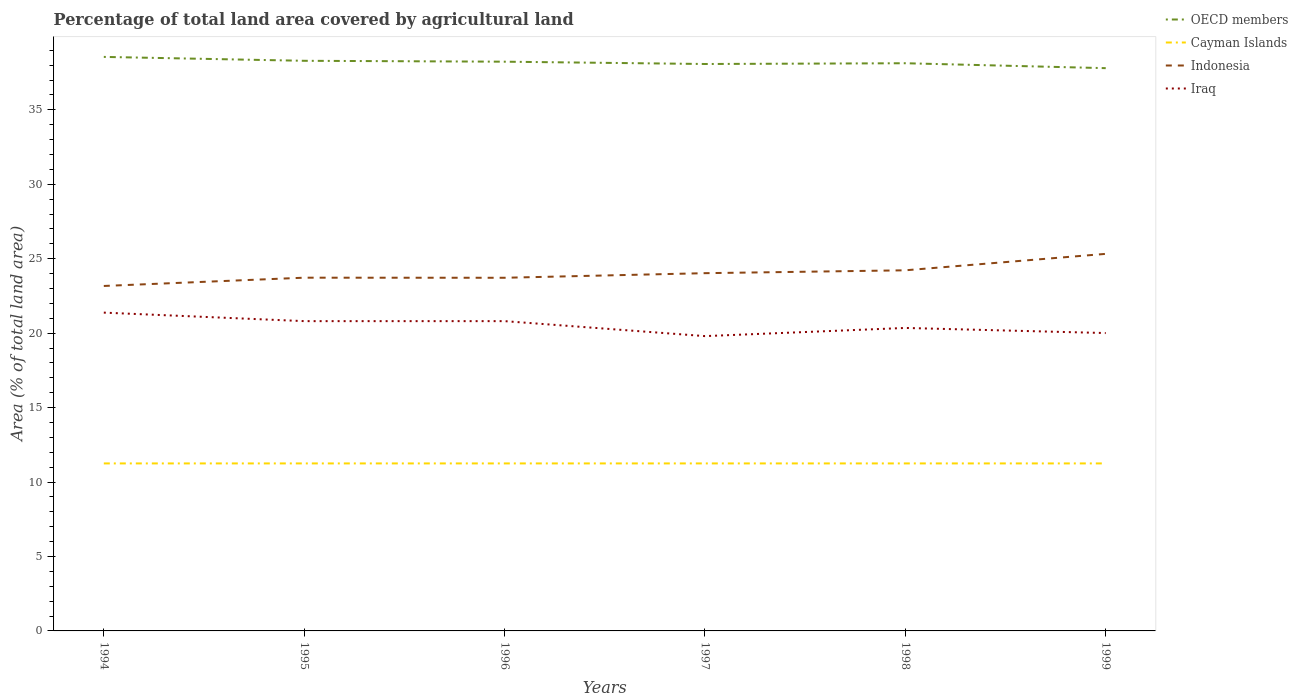Across all years, what is the maximum percentage of agricultural land in OECD members?
Offer a very short reply. 37.8. In which year was the percentage of agricultural land in Iraq maximum?
Your response must be concise. 1997. Is the percentage of agricultural land in Cayman Islands strictly greater than the percentage of agricultural land in OECD members over the years?
Your response must be concise. Yes. How many lines are there?
Provide a succinct answer. 4. Does the graph contain grids?
Your response must be concise. No. Where does the legend appear in the graph?
Provide a short and direct response. Top right. How are the legend labels stacked?
Offer a terse response. Vertical. What is the title of the graph?
Ensure brevity in your answer.  Percentage of total land area covered by agricultural land. Does "Other small states" appear as one of the legend labels in the graph?
Your response must be concise. No. What is the label or title of the X-axis?
Your answer should be compact. Years. What is the label or title of the Y-axis?
Give a very brief answer. Area (% of total land area). What is the Area (% of total land area) of OECD members in 1994?
Keep it short and to the point. 38.55. What is the Area (% of total land area) of Cayman Islands in 1994?
Your response must be concise. 11.25. What is the Area (% of total land area) of Indonesia in 1994?
Ensure brevity in your answer.  23.17. What is the Area (% of total land area) in Iraq in 1994?
Offer a terse response. 21.38. What is the Area (% of total land area) in OECD members in 1995?
Make the answer very short. 38.29. What is the Area (% of total land area) of Cayman Islands in 1995?
Provide a short and direct response. 11.25. What is the Area (% of total land area) of Indonesia in 1995?
Your response must be concise. 23.72. What is the Area (% of total land area) in Iraq in 1995?
Your response must be concise. 20.81. What is the Area (% of total land area) in OECD members in 1996?
Your answer should be very brief. 38.23. What is the Area (% of total land area) of Cayman Islands in 1996?
Your answer should be very brief. 11.25. What is the Area (% of total land area) in Indonesia in 1996?
Give a very brief answer. 23.72. What is the Area (% of total land area) in Iraq in 1996?
Your answer should be very brief. 20.81. What is the Area (% of total land area) of OECD members in 1997?
Provide a short and direct response. 38.08. What is the Area (% of total land area) in Cayman Islands in 1997?
Give a very brief answer. 11.25. What is the Area (% of total land area) in Indonesia in 1997?
Your response must be concise. 24.03. What is the Area (% of total land area) in Iraq in 1997?
Make the answer very short. 19.8. What is the Area (% of total land area) of OECD members in 1998?
Your response must be concise. 38.13. What is the Area (% of total land area) in Cayman Islands in 1998?
Offer a very short reply. 11.25. What is the Area (% of total land area) in Indonesia in 1998?
Offer a terse response. 24.22. What is the Area (% of total land area) in Iraq in 1998?
Provide a succinct answer. 20.35. What is the Area (% of total land area) in OECD members in 1999?
Ensure brevity in your answer.  37.8. What is the Area (% of total land area) of Cayman Islands in 1999?
Your response must be concise. 11.25. What is the Area (% of total land area) of Indonesia in 1999?
Your answer should be very brief. 25.32. What is the Area (% of total land area) in Iraq in 1999?
Make the answer very short. 20.01. Across all years, what is the maximum Area (% of total land area) of OECD members?
Your answer should be very brief. 38.55. Across all years, what is the maximum Area (% of total land area) of Cayman Islands?
Keep it short and to the point. 11.25. Across all years, what is the maximum Area (% of total land area) in Indonesia?
Keep it short and to the point. 25.32. Across all years, what is the maximum Area (% of total land area) in Iraq?
Keep it short and to the point. 21.38. Across all years, what is the minimum Area (% of total land area) of OECD members?
Offer a very short reply. 37.8. Across all years, what is the minimum Area (% of total land area) of Cayman Islands?
Your answer should be very brief. 11.25. Across all years, what is the minimum Area (% of total land area) of Indonesia?
Keep it short and to the point. 23.17. Across all years, what is the minimum Area (% of total land area) in Iraq?
Your response must be concise. 19.8. What is the total Area (% of total land area) of OECD members in the graph?
Your answer should be very brief. 229.07. What is the total Area (% of total land area) in Cayman Islands in the graph?
Give a very brief answer. 67.5. What is the total Area (% of total land area) of Indonesia in the graph?
Give a very brief answer. 144.18. What is the total Area (% of total land area) of Iraq in the graph?
Offer a terse response. 123.15. What is the difference between the Area (% of total land area) in OECD members in 1994 and that in 1995?
Your answer should be compact. 0.26. What is the difference between the Area (% of total land area) of Cayman Islands in 1994 and that in 1995?
Your response must be concise. 0. What is the difference between the Area (% of total land area) in Indonesia in 1994 and that in 1995?
Give a very brief answer. -0.56. What is the difference between the Area (% of total land area) in Iraq in 1994 and that in 1995?
Your response must be concise. 0.57. What is the difference between the Area (% of total land area) of OECD members in 1994 and that in 1996?
Ensure brevity in your answer.  0.32. What is the difference between the Area (% of total land area) of Cayman Islands in 1994 and that in 1996?
Provide a short and direct response. 0. What is the difference between the Area (% of total land area) of Indonesia in 1994 and that in 1996?
Ensure brevity in your answer.  -0.55. What is the difference between the Area (% of total land area) in Iraq in 1994 and that in 1996?
Provide a short and direct response. 0.57. What is the difference between the Area (% of total land area) of OECD members in 1994 and that in 1997?
Your answer should be compact. 0.48. What is the difference between the Area (% of total land area) of Cayman Islands in 1994 and that in 1997?
Ensure brevity in your answer.  0. What is the difference between the Area (% of total land area) in Indonesia in 1994 and that in 1997?
Keep it short and to the point. -0.86. What is the difference between the Area (% of total land area) of Iraq in 1994 and that in 1997?
Offer a terse response. 1.58. What is the difference between the Area (% of total land area) in OECD members in 1994 and that in 1998?
Your answer should be compact. 0.43. What is the difference between the Area (% of total land area) in Cayman Islands in 1994 and that in 1998?
Provide a succinct answer. 0. What is the difference between the Area (% of total land area) in Indonesia in 1994 and that in 1998?
Your answer should be very brief. -1.05. What is the difference between the Area (% of total land area) in Iraq in 1994 and that in 1998?
Provide a short and direct response. 1.03. What is the difference between the Area (% of total land area) of OECD members in 1994 and that in 1999?
Offer a terse response. 0.76. What is the difference between the Area (% of total land area) in Indonesia in 1994 and that in 1999?
Your answer should be very brief. -2.16. What is the difference between the Area (% of total land area) in Iraq in 1994 and that in 1999?
Ensure brevity in your answer.  1.37. What is the difference between the Area (% of total land area) of OECD members in 1995 and that in 1996?
Your answer should be compact. 0.06. What is the difference between the Area (% of total land area) in Indonesia in 1995 and that in 1996?
Your answer should be compact. 0.01. What is the difference between the Area (% of total land area) of OECD members in 1995 and that in 1997?
Ensure brevity in your answer.  0.22. What is the difference between the Area (% of total land area) in Indonesia in 1995 and that in 1997?
Give a very brief answer. -0.3. What is the difference between the Area (% of total land area) of OECD members in 1995 and that in 1998?
Offer a terse response. 0.16. What is the difference between the Area (% of total land area) of Indonesia in 1995 and that in 1998?
Offer a very short reply. -0.5. What is the difference between the Area (% of total land area) of Iraq in 1995 and that in 1998?
Your answer should be very brief. 0.46. What is the difference between the Area (% of total land area) of OECD members in 1995 and that in 1999?
Keep it short and to the point. 0.49. What is the difference between the Area (% of total land area) in Indonesia in 1995 and that in 1999?
Provide a succinct answer. -1.6. What is the difference between the Area (% of total land area) in Iraq in 1995 and that in 1999?
Provide a succinct answer. 0.8. What is the difference between the Area (% of total land area) of OECD members in 1996 and that in 1997?
Offer a terse response. 0.16. What is the difference between the Area (% of total land area) of Indonesia in 1996 and that in 1997?
Offer a very short reply. -0.31. What is the difference between the Area (% of total land area) in Iraq in 1996 and that in 1997?
Offer a very short reply. 1.01. What is the difference between the Area (% of total land area) in OECD members in 1996 and that in 1998?
Your answer should be very brief. 0.1. What is the difference between the Area (% of total land area) of Indonesia in 1996 and that in 1998?
Offer a terse response. -0.5. What is the difference between the Area (% of total land area) in Iraq in 1996 and that in 1998?
Make the answer very short. 0.46. What is the difference between the Area (% of total land area) of OECD members in 1996 and that in 1999?
Provide a succinct answer. 0.43. What is the difference between the Area (% of total land area) in Indonesia in 1996 and that in 1999?
Your answer should be very brief. -1.61. What is the difference between the Area (% of total land area) of Iraq in 1996 and that in 1999?
Make the answer very short. 0.8. What is the difference between the Area (% of total land area) of OECD members in 1997 and that in 1998?
Keep it short and to the point. -0.05. What is the difference between the Area (% of total land area) of Cayman Islands in 1997 and that in 1998?
Your response must be concise. 0. What is the difference between the Area (% of total land area) of Indonesia in 1997 and that in 1998?
Your answer should be compact. -0.19. What is the difference between the Area (% of total land area) of Iraq in 1997 and that in 1998?
Your response must be concise. -0.55. What is the difference between the Area (% of total land area) of OECD members in 1997 and that in 1999?
Your response must be concise. 0.28. What is the difference between the Area (% of total land area) of Indonesia in 1997 and that in 1999?
Offer a very short reply. -1.3. What is the difference between the Area (% of total land area) in Iraq in 1997 and that in 1999?
Your response must be concise. -0.21. What is the difference between the Area (% of total land area) in OECD members in 1998 and that in 1999?
Offer a terse response. 0.33. What is the difference between the Area (% of total land area) in Cayman Islands in 1998 and that in 1999?
Your answer should be compact. 0. What is the difference between the Area (% of total land area) of Indonesia in 1998 and that in 1999?
Ensure brevity in your answer.  -1.1. What is the difference between the Area (% of total land area) in Iraq in 1998 and that in 1999?
Provide a short and direct response. 0.34. What is the difference between the Area (% of total land area) in OECD members in 1994 and the Area (% of total land area) in Cayman Islands in 1995?
Your response must be concise. 27.3. What is the difference between the Area (% of total land area) of OECD members in 1994 and the Area (% of total land area) of Indonesia in 1995?
Offer a very short reply. 14.83. What is the difference between the Area (% of total land area) of OECD members in 1994 and the Area (% of total land area) of Iraq in 1995?
Offer a terse response. 17.75. What is the difference between the Area (% of total land area) of Cayman Islands in 1994 and the Area (% of total land area) of Indonesia in 1995?
Your response must be concise. -12.47. What is the difference between the Area (% of total land area) in Cayman Islands in 1994 and the Area (% of total land area) in Iraq in 1995?
Provide a succinct answer. -9.56. What is the difference between the Area (% of total land area) in Indonesia in 1994 and the Area (% of total land area) in Iraq in 1995?
Provide a short and direct response. 2.36. What is the difference between the Area (% of total land area) of OECD members in 1994 and the Area (% of total land area) of Cayman Islands in 1996?
Give a very brief answer. 27.3. What is the difference between the Area (% of total land area) of OECD members in 1994 and the Area (% of total land area) of Indonesia in 1996?
Keep it short and to the point. 14.83. What is the difference between the Area (% of total land area) of OECD members in 1994 and the Area (% of total land area) of Iraq in 1996?
Offer a terse response. 17.75. What is the difference between the Area (% of total land area) in Cayman Islands in 1994 and the Area (% of total land area) in Indonesia in 1996?
Make the answer very short. -12.47. What is the difference between the Area (% of total land area) in Cayman Islands in 1994 and the Area (% of total land area) in Iraq in 1996?
Give a very brief answer. -9.56. What is the difference between the Area (% of total land area) of Indonesia in 1994 and the Area (% of total land area) of Iraq in 1996?
Your answer should be very brief. 2.36. What is the difference between the Area (% of total land area) in OECD members in 1994 and the Area (% of total land area) in Cayman Islands in 1997?
Offer a very short reply. 27.3. What is the difference between the Area (% of total land area) of OECD members in 1994 and the Area (% of total land area) of Indonesia in 1997?
Offer a terse response. 14.53. What is the difference between the Area (% of total land area) of OECD members in 1994 and the Area (% of total land area) of Iraq in 1997?
Offer a terse response. 18.75. What is the difference between the Area (% of total land area) in Cayman Islands in 1994 and the Area (% of total land area) in Indonesia in 1997?
Make the answer very short. -12.78. What is the difference between the Area (% of total land area) of Cayman Islands in 1994 and the Area (% of total land area) of Iraq in 1997?
Provide a succinct answer. -8.55. What is the difference between the Area (% of total land area) of Indonesia in 1994 and the Area (% of total land area) of Iraq in 1997?
Offer a terse response. 3.37. What is the difference between the Area (% of total land area) of OECD members in 1994 and the Area (% of total land area) of Cayman Islands in 1998?
Make the answer very short. 27.3. What is the difference between the Area (% of total land area) in OECD members in 1994 and the Area (% of total land area) in Indonesia in 1998?
Keep it short and to the point. 14.33. What is the difference between the Area (% of total land area) in OECD members in 1994 and the Area (% of total land area) in Iraq in 1998?
Your answer should be very brief. 18.2. What is the difference between the Area (% of total land area) of Cayman Islands in 1994 and the Area (% of total land area) of Indonesia in 1998?
Give a very brief answer. -12.97. What is the difference between the Area (% of total land area) in Cayman Islands in 1994 and the Area (% of total land area) in Iraq in 1998?
Give a very brief answer. -9.1. What is the difference between the Area (% of total land area) of Indonesia in 1994 and the Area (% of total land area) of Iraq in 1998?
Offer a very short reply. 2.82. What is the difference between the Area (% of total land area) in OECD members in 1994 and the Area (% of total land area) in Cayman Islands in 1999?
Your response must be concise. 27.3. What is the difference between the Area (% of total land area) in OECD members in 1994 and the Area (% of total land area) in Indonesia in 1999?
Give a very brief answer. 13.23. What is the difference between the Area (% of total land area) in OECD members in 1994 and the Area (% of total land area) in Iraq in 1999?
Your response must be concise. 18.55. What is the difference between the Area (% of total land area) in Cayman Islands in 1994 and the Area (% of total land area) in Indonesia in 1999?
Give a very brief answer. -14.07. What is the difference between the Area (% of total land area) of Cayman Islands in 1994 and the Area (% of total land area) of Iraq in 1999?
Offer a very short reply. -8.76. What is the difference between the Area (% of total land area) of Indonesia in 1994 and the Area (% of total land area) of Iraq in 1999?
Your answer should be compact. 3.16. What is the difference between the Area (% of total land area) of OECD members in 1995 and the Area (% of total land area) of Cayman Islands in 1996?
Give a very brief answer. 27.04. What is the difference between the Area (% of total land area) in OECD members in 1995 and the Area (% of total land area) in Indonesia in 1996?
Make the answer very short. 14.57. What is the difference between the Area (% of total land area) in OECD members in 1995 and the Area (% of total land area) in Iraq in 1996?
Offer a terse response. 17.49. What is the difference between the Area (% of total land area) of Cayman Islands in 1995 and the Area (% of total land area) of Indonesia in 1996?
Your answer should be very brief. -12.47. What is the difference between the Area (% of total land area) in Cayman Islands in 1995 and the Area (% of total land area) in Iraq in 1996?
Offer a very short reply. -9.56. What is the difference between the Area (% of total land area) of Indonesia in 1995 and the Area (% of total land area) of Iraq in 1996?
Offer a very short reply. 2.92. What is the difference between the Area (% of total land area) of OECD members in 1995 and the Area (% of total land area) of Cayman Islands in 1997?
Your response must be concise. 27.04. What is the difference between the Area (% of total land area) of OECD members in 1995 and the Area (% of total land area) of Indonesia in 1997?
Offer a terse response. 14.26. What is the difference between the Area (% of total land area) of OECD members in 1995 and the Area (% of total land area) of Iraq in 1997?
Your answer should be very brief. 18.49. What is the difference between the Area (% of total land area) in Cayman Islands in 1995 and the Area (% of total land area) in Indonesia in 1997?
Your answer should be very brief. -12.78. What is the difference between the Area (% of total land area) in Cayman Islands in 1995 and the Area (% of total land area) in Iraq in 1997?
Your answer should be compact. -8.55. What is the difference between the Area (% of total land area) in Indonesia in 1995 and the Area (% of total land area) in Iraq in 1997?
Provide a succinct answer. 3.92. What is the difference between the Area (% of total land area) in OECD members in 1995 and the Area (% of total land area) in Cayman Islands in 1998?
Your answer should be very brief. 27.04. What is the difference between the Area (% of total land area) in OECD members in 1995 and the Area (% of total land area) in Indonesia in 1998?
Offer a terse response. 14.07. What is the difference between the Area (% of total land area) of OECD members in 1995 and the Area (% of total land area) of Iraq in 1998?
Give a very brief answer. 17.94. What is the difference between the Area (% of total land area) of Cayman Islands in 1995 and the Area (% of total land area) of Indonesia in 1998?
Provide a short and direct response. -12.97. What is the difference between the Area (% of total land area) in Cayman Islands in 1995 and the Area (% of total land area) in Iraq in 1998?
Your answer should be compact. -9.1. What is the difference between the Area (% of total land area) of Indonesia in 1995 and the Area (% of total land area) of Iraq in 1998?
Give a very brief answer. 3.38. What is the difference between the Area (% of total land area) in OECD members in 1995 and the Area (% of total land area) in Cayman Islands in 1999?
Keep it short and to the point. 27.04. What is the difference between the Area (% of total land area) in OECD members in 1995 and the Area (% of total land area) in Indonesia in 1999?
Provide a short and direct response. 12.97. What is the difference between the Area (% of total land area) of OECD members in 1995 and the Area (% of total land area) of Iraq in 1999?
Your response must be concise. 18.29. What is the difference between the Area (% of total land area) in Cayman Islands in 1995 and the Area (% of total land area) in Indonesia in 1999?
Your response must be concise. -14.07. What is the difference between the Area (% of total land area) of Cayman Islands in 1995 and the Area (% of total land area) of Iraq in 1999?
Offer a very short reply. -8.76. What is the difference between the Area (% of total land area) in Indonesia in 1995 and the Area (% of total land area) in Iraq in 1999?
Offer a terse response. 3.72. What is the difference between the Area (% of total land area) of OECD members in 1996 and the Area (% of total land area) of Cayman Islands in 1997?
Your answer should be compact. 26.98. What is the difference between the Area (% of total land area) in OECD members in 1996 and the Area (% of total land area) in Indonesia in 1997?
Make the answer very short. 14.2. What is the difference between the Area (% of total land area) in OECD members in 1996 and the Area (% of total land area) in Iraq in 1997?
Your answer should be very brief. 18.43. What is the difference between the Area (% of total land area) in Cayman Islands in 1996 and the Area (% of total land area) in Indonesia in 1997?
Your response must be concise. -12.78. What is the difference between the Area (% of total land area) of Cayman Islands in 1996 and the Area (% of total land area) of Iraq in 1997?
Provide a short and direct response. -8.55. What is the difference between the Area (% of total land area) of Indonesia in 1996 and the Area (% of total land area) of Iraq in 1997?
Your response must be concise. 3.92. What is the difference between the Area (% of total land area) in OECD members in 1996 and the Area (% of total land area) in Cayman Islands in 1998?
Give a very brief answer. 26.98. What is the difference between the Area (% of total land area) in OECD members in 1996 and the Area (% of total land area) in Indonesia in 1998?
Your answer should be compact. 14.01. What is the difference between the Area (% of total land area) in OECD members in 1996 and the Area (% of total land area) in Iraq in 1998?
Your answer should be compact. 17.88. What is the difference between the Area (% of total land area) of Cayman Islands in 1996 and the Area (% of total land area) of Indonesia in 1998?
Give a very brief answer. -12.97. What is the difference between the Area (% of total land area) in Cayman Islands in 1996 and the Area (% of total land area) in Iraq in 1998?
Offer a terse response. -9.1. What is the difference between the Area (% of total land area) of Indonesia in 1996 and the Area (% of total land area) of Iraq in 1998?
Your answer should be compact. 3.37. What is the difference between the Area (% of total land area) of OECD members in 1996 and the Area (% of total land area) of Cayman Islands in 1999?
Your response must be concise. 26.98. What is the difference between the Area (% of total land area) in OECD members in 1996 and the Area (% of total land area) in Indonesia in 1999?
Make the answer very short. 12.91. What is the difference between the Area (% of total land area) of OECD members in 1996 and the Area (% of total land area) of Iraq in 1999?
Your answer should be very brief. 18.23. What is the difference between the Area (% of total land area) in Cayman Islands in 1996 and the Area (% of total land area) in Indonesia in 1999?
Give a very brief answer. -14.07. What is the difference between the Area (% of total land area) of Cayman Islands in 1996 and the Area (% of total land area) of Iraq in 1999?
Make the answer very short. -8.76. What is the difference between the Area (% of total land area) in Indonesia in 1996 and the Area (% of total land area) in Iraq in 1999?
Keep it short and to the point. 3.71. What is the difference between the Area (% of total land area) of OECD members in 1997 and the Area (% of total land area) of Cayman Islands in 1998?
Your answer should be compact. 26.83. What is the difference between the Area (% of total land area) of OECD members in 1997 and the Area (% of total land area) of Indonesia in 1998?
Give a very brief answer. 13.86. What is the difference between the Area (% of total land area) of OECD members in 1997 and the Area (% of total land area) of Iraq in 1998?
Ensure brevity in your answer.  17.73. What is the difference between the Area (% of total land area) in Cayman Islands in 1997 and the Area (% of total land area) in Indonesia in 1998?
Provide a succinct answer. -12.97. What is the difference between the Area (% of total land area) of Cayman Islands in 1997 and the Area (% of total land area) of Iraq in 1998?
Keep it short and to the point. -9.1. What is the difference between the Area (% of total land area) of Indonesia in 1997 and the Area (% of total land area) of Iraq in 1998?
Your answer should be very brief. 3.68. What is the difference between the Area (% of total land area) of OECD members in 1997 and the Area (% of total land area) of Cayman Islands in 1999?
Your response must be concise. 26.83. What is the difference between the Area (% of total land area) of OECD members in 1997 and the Area (% of total land area) of Indonesia in 1999?
Keep it short and to the point. 12.75. What is the difference between the Area (% of total land area) of OECD members in 1997 and the Area (% of total land area) of Iraq in 1999?
Your answer should be very brief. 18.07. What is the difference between the Area (% of total land area) in Cayman Islands in 1997 and the Area (% of total land area) in Indonesia in 1999?
Provide a succinct answer. -14.07. What is the difference between the Area (% of total land area) of Cayman Islands in 1997 and the Area (% of total land area) of Iraq in 1999?
Your answer should be compact. -8.76. What is the difference between the Area (% of total land area) in Indonesia in 1997 and the Area (% of total land area) in Iraq in 1999?
Provide a succinct answer. 4.02. What is the difference between the Area (% of total land area) of OECD members in 1998 and the Area (% of total land area) of Cayman Islands in 1999?
Provide a short and direct response. 26.88. What is the difference between the Area (% of total land area) in OECD members in 1998 and the Area (% of total land area) in Indonesia in 1999?
Make the answer very short. 12.8. What is the difference between the Area (% of total land area) in OECD members in 1998 and the Area (% of total land area) in Iraq in 1999?
Your response must be concise. 18.12. What is the difference between the Area (% of total land area) in Cayman Islands in 1998 and the Area (% of total land area) in Indonesia in 1999?
Make the answer very short. -14.07. What is the difference between the Area (% of total land area) of Cayman Islands in 1998 and the Area (% of total land area) of Iraq in 1999?
Provide a succinct answer. -8.76. What is the difference between the Area (% of total land area) of Indonesia in 1998 and the Area (% of total land area) of Iraq in 1999?
Offer a very short reply. 4.21. What is the average Area (% of total land area) of OECD members per year?
Provide a succinct answer. 38.18. What is the average Area (% of total land area) of Cayman Islands per year?
Your response must be concise. 11.25. What is the average Area (% of total land area) of Indonesia per year?
Your answer should be compact. 24.03. What is the average Area (% of total land area) of Iraq per year?
Your answer should be very brief. 20.52. In the year 1994, what is the difference between the Area (% of total land area) in OECD members and Area (% of total land area) in Cayman Islands?
Provide a short and direct response. 27.3. In the year 1994, what is the difference between the Area (% of total land area) of OECD members and Area (% of total land area) of Indonesia?
Make the answer very short. 15.38. In the year 1994, what is the difference between the Area (% of total land area) in OECD members and Area (% of total land area) in Iraq?
Ensure brevity in your answer.  17.17. In the year 1994, what is the difference between the Area (% of total land area) of Cayman Islands and Area (% of total land area) of Indonesia?
Your answer should be compact. -11.92. In the year 1994, what is the difference between the Area (% of total land area) of Cayman Islands and Area (% of total land area) of Iraq?
Your answer should be compact. -10.13. In the year 1994, what is the difference between the Area (% of total land area) in Indonesia and Area (% of total land area) in Iraq?
Make the answer very short. 1.79. In the year 1995, what is the difference between the Area (% of total land area) of OECD members and Area (% of total land area) of Cayman Islands?
Offer a very short reply. 27.04. In the year 1995, what is the difference between the Area (% of total land area) of OECD members and Area (% of total land area) of Indonesia?
Provide a short and direct response. 14.57. In the year 1995, what is the difference between the Area (% of total land area) in OECD members and Area (% of total land area) in Iraq?
Offer a very short reply. 17.49. In the year 1995, what is the difference between the Area (% of total land area) in Cayman Islands and Area (% of total land area) in Indonesia?
Your response must be concise. -12.47. In the year 1995, what is the difference between the Area (% of total land area) of Cayman Islands and Area (% of total land area) of Iraq?
Your response must be concise. -9.56. In the year 1995, what is the difference between the Area (% of total land area) of Indonesia and Area (% of total land area) of Iraq?
Give a very brief answer. 2.92. In the year 1996, what is the difference between the Area (% of total land area) of OECD members and Area (% of total land area) of Cayman Islands?
Offer a very short reply. 26.98. In the year 1996, what is the difference between the Area (% of total land area) of OECD members and Area (% of total land area) of Indonesia?
Provide a short and direct response. 14.51. In the year 1996, what is the difference between the Area (% of total land area) in OECD members and Area (% of total land area) in Iraq?
Give a very brief answer. 17.43. In the year 1996, what is the difference between the Area (% of total land area) in Cayman Islands and Area (% of total land area) in Indonesia?
Your answer should be compact. -12.47. In the year 1996, what is the difference between the Area (% of total land area) of Cayman Islands and Area (% of total land area) of Iraq?
Provide a short and direct response. -9.56. In the year 1996, what is the difference between the Area (% of total land area) of Indonesia and Area (% of total land area) of Iraq?
Offer a very short reply. 2.91. In the year 1997, what is the difference between the Area (% of total land area) of OECD members and Area (% of total land area) of Cayman Islands?
Provide a succinct answer. 26.83. In the year 1997, what is the difference between the Area (% of total land area) of OECD members and Area (% of total land area) of Indonesia?
Your answer should be compact. 14.05. In the year 1997, what is the difference between the Area (% of total land area) in OECD members and Area (% of total land area) in Iraq?
Offer a very short reply. 18.28. In the year 1997, what is the difference between the Area (% of total land area) in Cayman Islands and Area (% of total land area) in Indonesia?
Provide a succinct answer. -12.78. In the year 1997, what is the difference between the Area (% of total land area) of Cayman Islands and Area (% of total land area) of Iraq?
Ensure brevity in your answer.  -8.55. In the year 1997, what is the difference between the Area (% of total land area) of Indonesia and Area (% of total land area) of Iraq?
Offer a very short reply. 4.23. In the year 1998, what is the difference between the Area (% of total land area) in OECD members and Area (% of total land area) in Cayman Islands?
Your response must be concise. 26.88. In the year 1998, what is the difference between the Area (% of total land area) in OECD members and Area (% of total land area) in Indonesia?
Offer a terse response. 13.91. In the year 1998, what is the difference between the Area (% of total land area) of OECD members and Area (% of total land area) of Iraq?
Your response must be concise. 17.78. In the year 1998, what is the difference between the Area (% of total land area) in Cayman Islands and Area (% of total land area) in Indonesia?
Ensure brevity in your answer.  -12.97. In the year 1998, what is the difference between the Area (% of total land area) of Cayman Islands and Area (% of total land area) of Iraq?
Give a very brief answer. -9.1. In the year 1998, what is the difference between the Area (% of total land area) in Indonesia and Area (% of total land area) in Iraq?
Keep it short and to the point. 3.87. In the year 1999, what is the difference between the Area (% of total land area) of OECD members and Area (% of total land area) of Cayman Islands?
Your response must be concise. 26.55. In the year 1999, what is the difference between the Area (% of total land area) in OECD members and Area (% of total land area) in Indonesia?
Your answer should be compact. 12.47. In the year 1999, what is the difference between the Area (% of total land area) of OECD members and Area (% of total land area) of Iraq?
Provide a succinct answer. 17.79. In the year 1999, what is the difference between the Area (% of total land area) in Cayman Islands and Area (% of total land area) in Indonesia?
Keep it short and to the point. -14.07. In the year 1999, what is the difference between the Area (% of total land area) of Cayman Islands and Area (% of total land area) of Iraq?
Ensure brevity in your answer.  -8.76. In the year 1999, what is the difference between the Area (% of total land area) of Indonesia and Area (% of total land area) of Iraq?
Your answer should be compact. 5.32. What is the ratio of the Area (% of total land area) in OECD members in 1994 to that in 1995?
Your answer should be very brief. 1.01. What is the ratio of the Area (% of total land area) in Indonesia in 1994 to that in 1995?
Give a very brief answer. 0.98. What is the ratio of the Area (% of total land area) of Iraq in 1994 to that in 1995?
Ensure brevity in your answer.  1.03. What is the ratio of the Area (% of total land area) of OECD members in 1994 to that in 1996?
Provide a succinct answer. 1.01. What is the ratio of the Area (% of total land area) in Cayman Islands in 1994 to that in 1996?
Ensure brevity in your answer.  1. What is the ratio of the Area (% of total land area) of Indonesia in 1994 to that in 1996?
Ensure brevity in your answer.  0.98. What is the ratio of the Area (% of total land area) in Iraq in 1994 to that in 1996?
Your answer should be very brief. 1.03. What is the ratio of the Area (% of total land area) in OECD members in 1994 to that in 1997?
Your answer should be very brief. 1.01. What is the ratio of the Area (% of total land area) in Indonesia in 1994 to that in 1997?
Keep it short and to the point. 0.96. What is the ratio of the Area (% of total land area) of Iraq in 1994 to that in 1997?
Provide a short and direct response. 1.08. What is the ratio of the Area (% of total land area) of OECD members in 1994 to that in 1998?
Provide a succinct answer. 1.01. What is the ratio of the Area (% of total land area) of Indonesia in 1994 to that in 1998?
Give a very brief answer. 0.96. What is the ratio of the Area (% of total land area) in Iraq in 1994 to that in 1998?
Ensure brevity in your answer.  1.05. What is the ratio of the Area (% of total land area) of Cayman Islands in 1994 to that in 1999?
Give a very brief answer. 1. What is the ratio of the Area (% of total land area) of Indonesia in 1994 to that in 1999?
Give a very brief answer. 0.91. What is the ratio of the Area (% of total land area) of Iraq in 1994 to that in 1999?
Ensure brevity in your answer.  1.07. What is the ratio of the Area (% of total land area) of Cayman Islands in 1995 to that in 1996?
Make the answer very short. 1. What is the ratio of the Area (% of total land area) of OECD members in 1995 to that in 1997?
Ensure brevity in your answer.  1.01. What is the ratio of the Area (% of total land area) of Indonesia in 1995 to that in 1997?
Offer a very short reply. 0.99. What is the ratio of the Area (% of total land area) in Iraq in 1995 to that in 1997?
Provide a short and direct response. 1.05. What is the ratio of the Area (% of total land area) in Indonesia in 1995 to that in 1998?
Your answer should be compact. 0.98. What is the ratio of the Area (% of total land area) of Iraq in 1995 to that in 1998?
Offer a very short reply. 1.02. What is the ratio of the Area (% of total land area) in OECD members in 1995 to that in 1999?
Offer a very short reply. 1.01. What is the ratio of the Area (% of total land area) of Indonesia in 1995 to that in 1999?
Make the answer very short. 0.94. What is the ratio of the Area (% of total land area) in Iraq in 1995 to that in 1999?
Your response must be concise. 1.04. What is the ratio of the Area (% of total land area) of OECD members in 1996 to that in 1997?
Your response must be concise. 1. What is the ratio of the Area (% of total land area) in Cayman Islands in 1996 to that in 1997?
Ensure brevity in your answer.  1. What is the ratio of the Area (% of total land area) in Indonesia in 1996 to that in 1997?
Keep it short and to the point. 0.99. What is the ratio of the Area (% of total land area) in Iraq in 1996 to that in 1997?
Your answer should be compact. 1.05. What is the ratio of the Area (% of total land area) of Cayman Islands in 1996 to that in 1998?
Your answer should be very brief. 1. What is the ratio of the Area (% of total land area) of Indonesia in 1996 to that in 1998?
Ensure brevity in your answer.  0.98. What is the ratio of the Area (% of total land area) of Iraq in 1996 to that in 1998?
Keep it short and to the point. 1.02. What is the ratio of the Area (% of total land area) of OECD members in 1996 to that in 1999?
Make the answer very short. 1.01. What is the ratio of the Area (% of total land area) of Indonesia in 1996 to that in 1999?
Your answer should be very brief. 0.94. What is the ratio of the Area (% of total land area) of OECD members in 1997 to that in 1999?
Offer a terse response. 1.01. What is the ratio of the Area (% of total land area) in Cayman Islands in 1997 to that in 1999?
Ensure brevity in your answer.  1. What is the ratio of the Area (% of total land area) of Indonesia in 1997 to that in 1999?
Make the answer very short. 0.95. What is the ratio of the Area (% of total land area) in OECD members in 1998 to that in 1999?
Make the answer very short. 1.01. What is the ratio of the Area (% of total land area) of Cayman Islands in 1998 to that in 1999?
Make the answer very short. 1. What is the ratio of the Area (% of total land area) of Indonesia in 1998 to that in 1999?
Provide a succinct answer. 0.96. What is the ratio of the Area (% of total land area) of Iraq in 1998 to that in 1999?
Provide a short and direct response. 1.02. What is the difference between the highest and the second highest Area (% of total land area) in OECD members?
Provide a short and direct response. 0.26. What is the difference between the highest and the second highest Area (% of total land area) in Cayman Islands?
Your response must be concise. 0. What is the difference between the highest and the second highest Area (% of total land area) in Indonesia?
Offer a terse response. 1.1. What is the difference between the highest and the second highest Area (% of total land area) of Iraq?
Your response must be concise. 0.57. What is the difference between the highest and the lowest Area (% of total land area) of OECD members?
Offer a terse response. 0.76. What is the difference between the highest and the lowest Area (% of total land area) of Indonesia?
Provide a short and direct response. 2.16. What is the difference between the highest and the lowest Area (% of total land area) of Iraq?
Give a very brief answer. 1.58. 